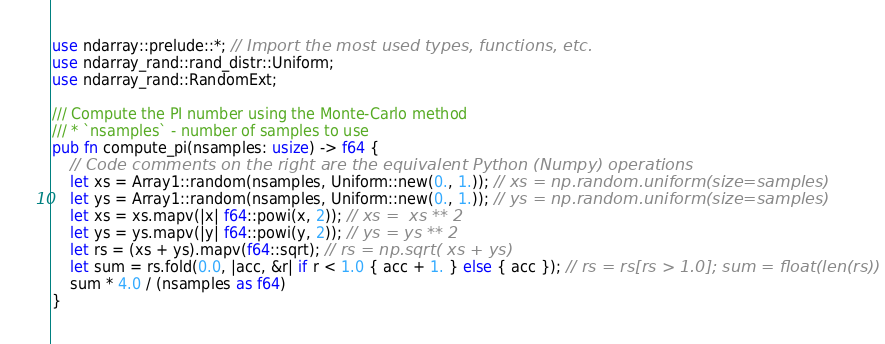<code> <loc_0><loc_0><loc_500><loc_500><_Rust_>
use ndarray::prelude::*; // Import the most used types, functions, etc.
use ndarray_rand::rand_distr::Uniform;
use ndarray_rand::RandomExt;

/// Compute the PI number using the Monte-Carlo method
/// * `nsamples` - number of samples to use
pub fn compute_pi(nsamples: usize) -> f64 {
    // Code comments on the right are the equivalent Python (Numpy) operations
    let xs = Array1::random(nsamples, Uniform::new(0., 1.)); // xs = np.random.uniform(size=samples)
    let ys = Array1::random(nsamples, Uniform::new(0., 1.)); // ys = np.random.uniform(size=samples)
    let xs = xs.mapv(|x| f64::powi(x, 2)); // xs =  xs ** 2
    let ys = ys.mapv(|y| f64::powi(y, 2)); // ys = ys ** 2
    let rs = (xs + ys).mapv(f64::sqrt); // rs = np.sqrt( xs + ys)
    let sum = rs.fold(0.0, |acc, &r| if r < 1.0 { acc + 1. } else { acc }); // rs = rs[rs > 1.0]; sum = float(len(rs))
    sum * 4.0 / (nsamples as f64)
}
</code> 